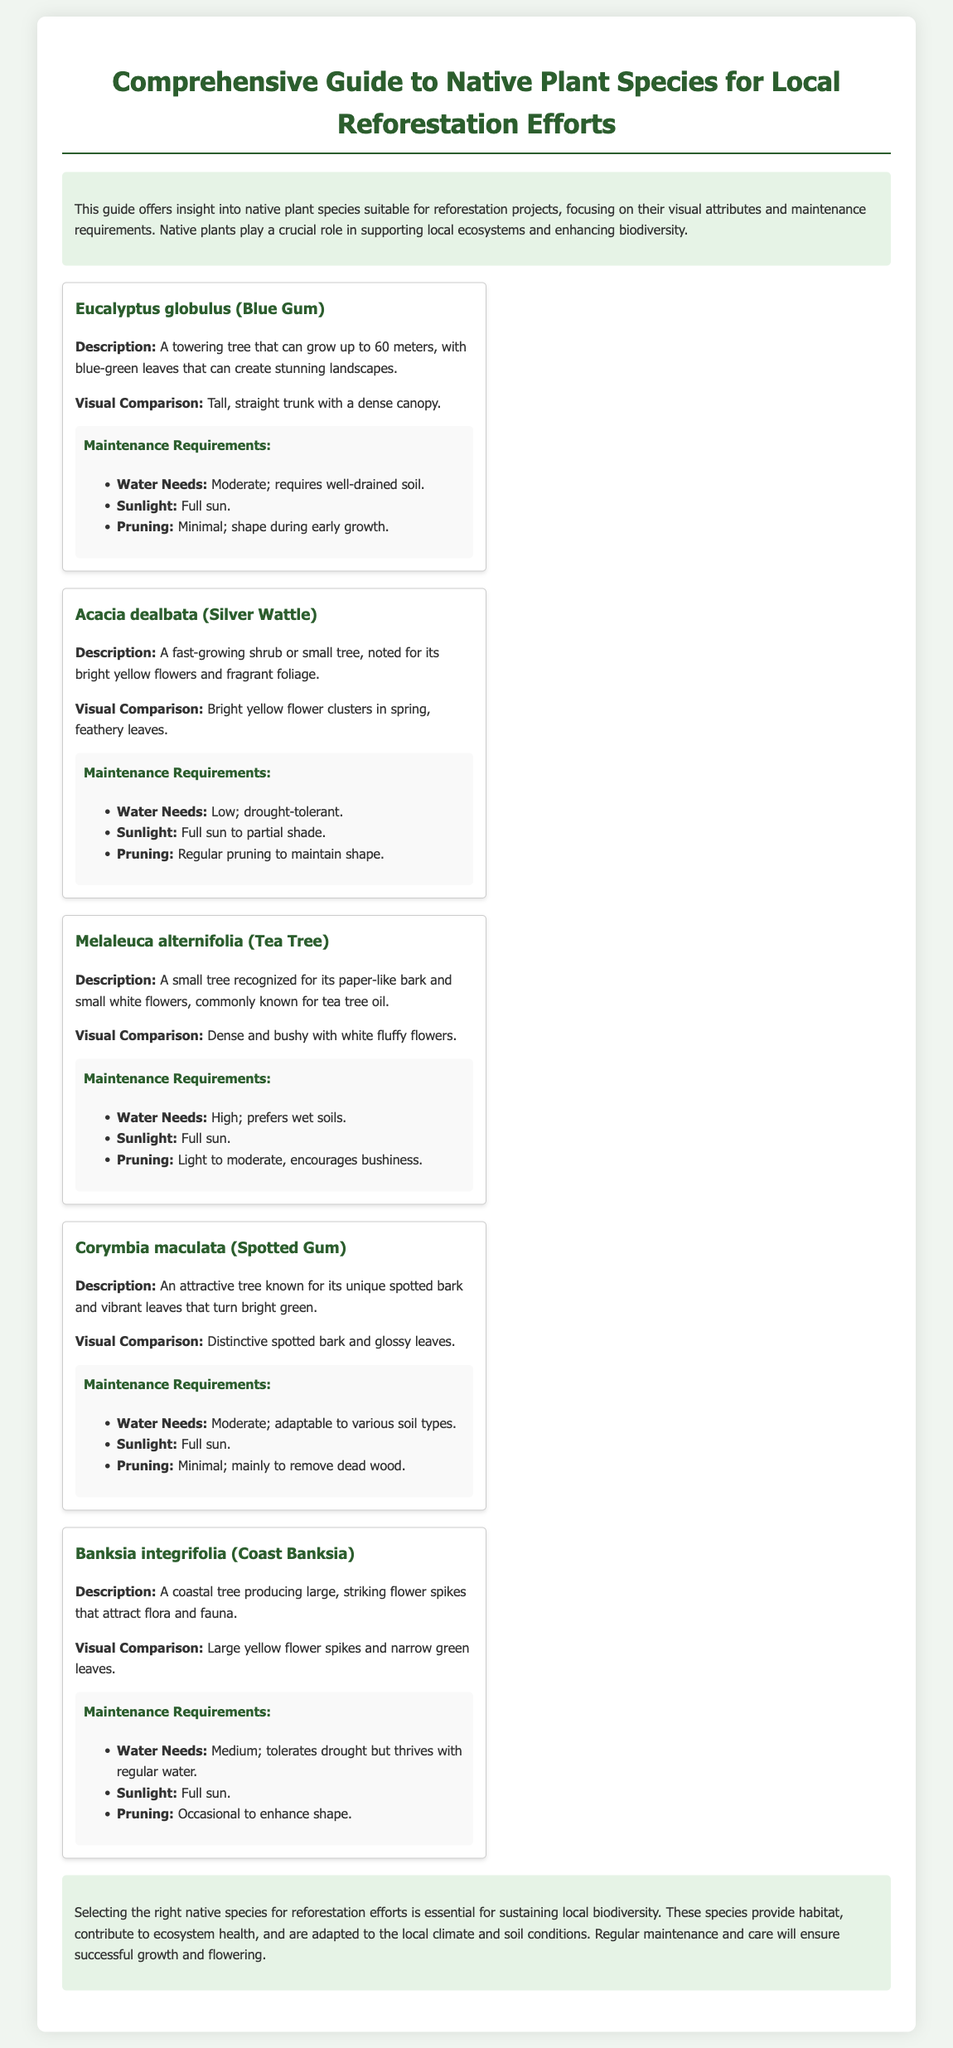What is the title of the document? The title of the document is presented prominently at the top of the page.
Answer: Comprehensive Guide to Native Plant Species for Local Reforestation Efforts How many native plant species are described in the guide? The document contains multiple species descriptions, specifically listing five species.
Answer: Five What is the maintenance requirement for Eucalyptus globulus regarding sunlight? The sunlight requirement is explicitly mentioned in the maintenance section for Eucalyptus globulus.
Answer: Full sun Which species has the highest water needs? The water needs are outlined for each species, indicating which one requires high moisture.
Answer: Melaleuca alternifolia What visual characteristic distinguishes Acacia dealbata? The document describes visual comparisons for each species, highlighting specific characteristics.
Answer: Bright yellow flower clusters Which species is described as drought-tolerant? The maintenance requirements include water needs, where drought tolerance is noted.
Answer: Acacia dealbata What is the typical height range for Eucalyptus globulus? The tree height is mentioned in the description section for Eucalyptus globulus.
Answer: Up to 60 meters What type of soil does Corymbia maculata adapt to? The document states specific adaptability in the maintenance section for Corymbia maculata.
Answer: Various soil types 